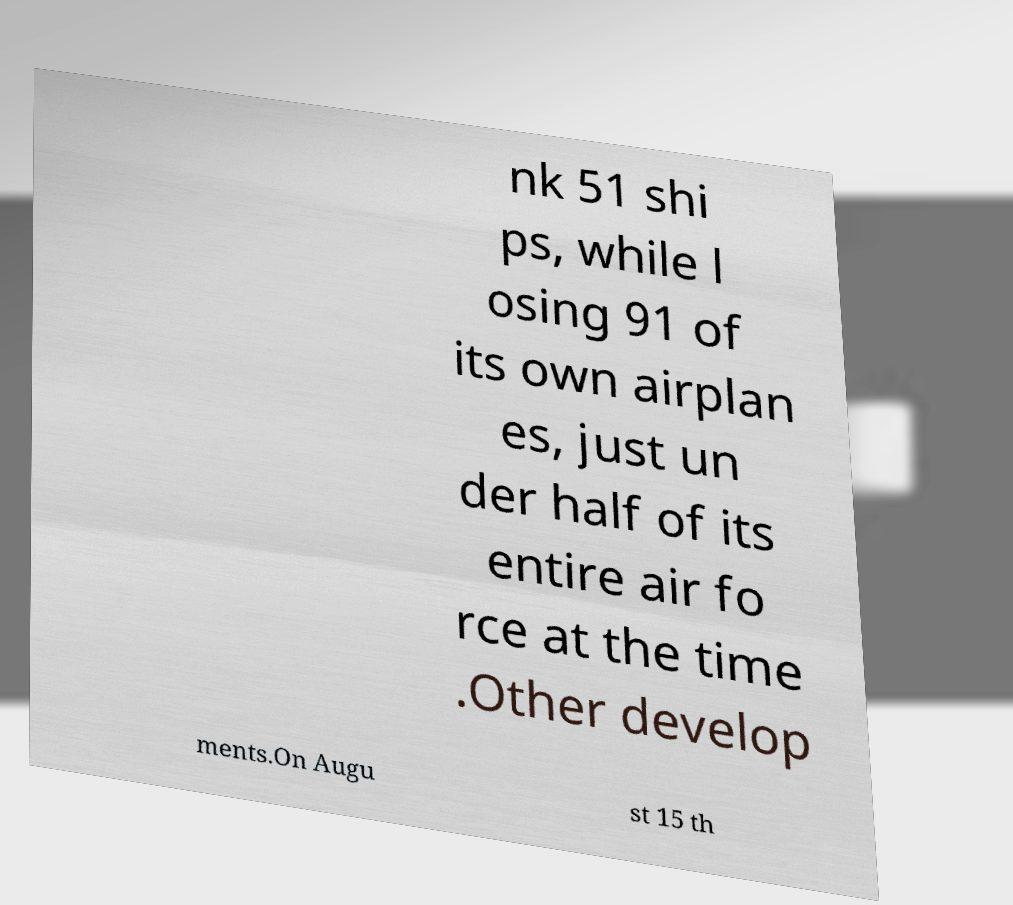What messages or text are displayed in this image? I need them in a readable, typed format. nk 51 shi ps, while l osing 91 of its own airplan es, just un der half of its entire air fo rce at the time .Other develop ments.On Augu st 15 th 